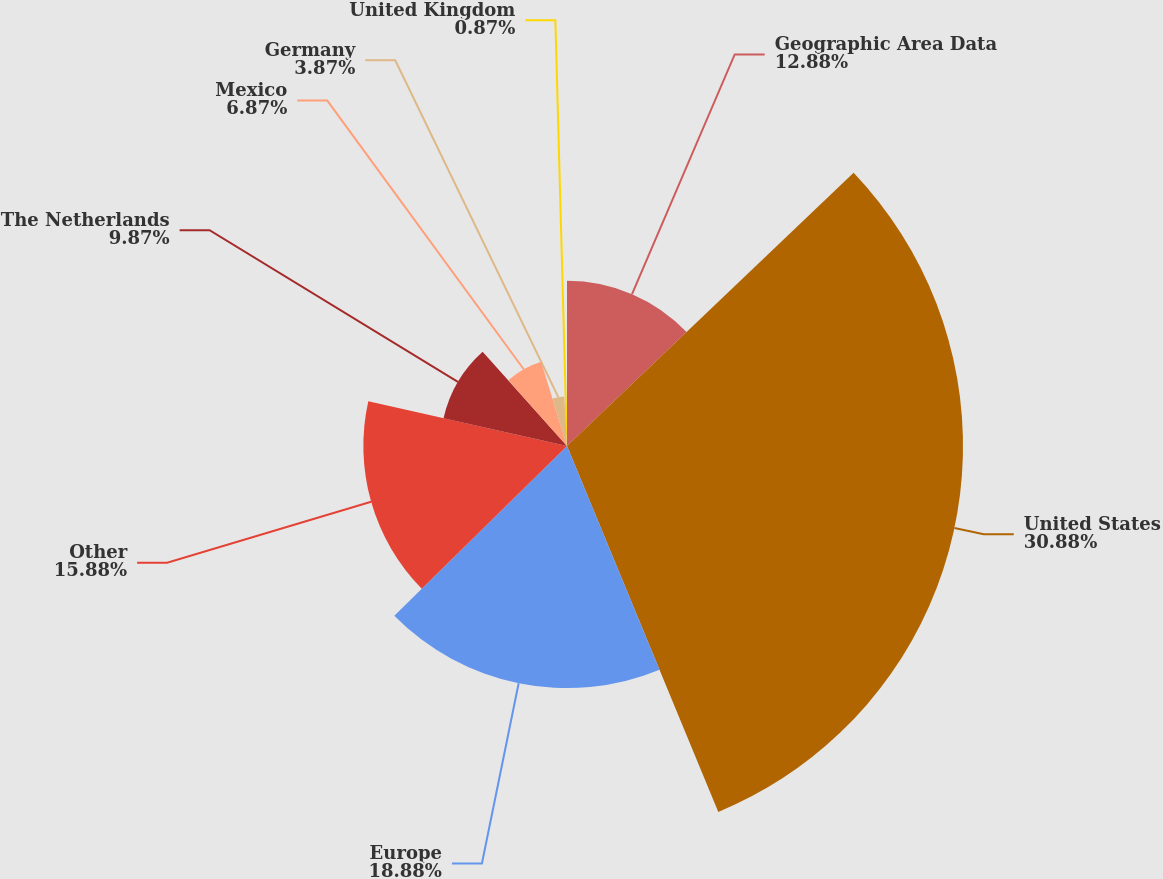<chart> <loc_0><loc_0><loc_500><loc_500><pie_chart><fcel>Geographic Area Data<fcel>United States<fcel>Europe<fcel>Other<fcel>The Netherlands<fcel>Mexico<fcel>Germany<fcel>United Kingdom<nl><fcel>12.88%<fcel>30.88%<fcel>18.88%<fcel>15.88%<fcel>9.87%<fcel>6.87%<fcel>3.87%<fcel>0.87%<nl></chart> 